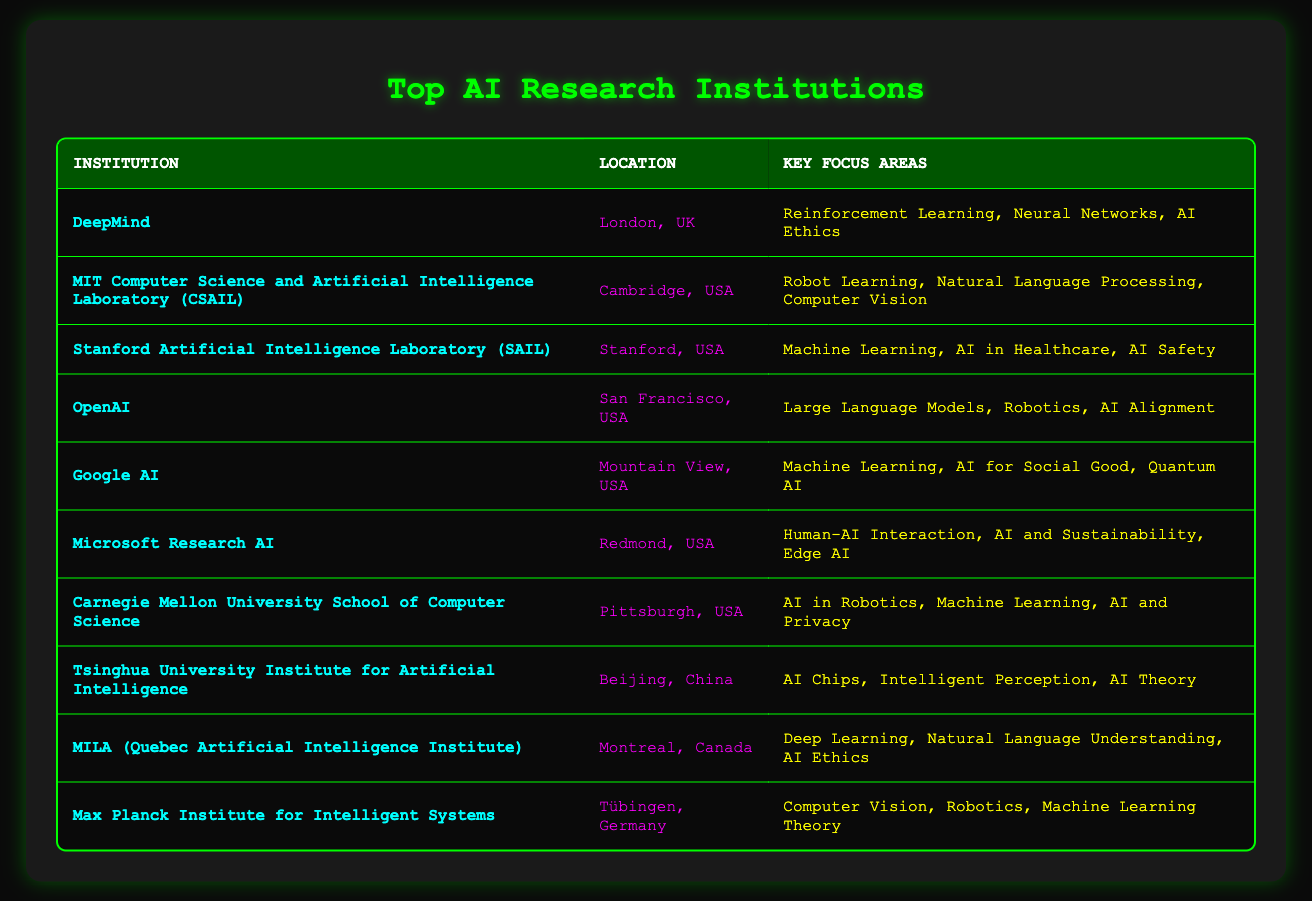What is the key focus area of DeepMind? The table shows that DeepMind's key focus areas are Reinforcement Learning, Neural Networks, and AI Ethics, which can be directly found in the row for DeepMind.
Answer: Reinforcement Learning, Neural Networks, AI Ethics Which institution is located in Cambridge, USA? By checking the 'Location' column in the table, MIT Computer Science and Artificial Intelligence Laboratory (CSAIL) is listed as located in Cambridge, USA.
Answer: MIT Computer Science and Artificial Intelligence Laboratory (CSAIL) Is Tsinghua University Institute for Artificial Intelligence focused on AI Ethics? The 'Key Focus Areas' for Tsinghua University are AI Chips, Intelligent Perception, and AI Theory. Since AI Ethics is not listed, the answer is no.
Answer: No Which two institutions focus on AI Ethics? The focus area column indicates that both DeepMind and MILA have AI Ethics listed among their key focus areas. Thus, they are the two institutions that focus on AI Ethics.
Answer: DeepMind, MILA How many institutions focus on Machine Learning? The focus areas indicate that DeepMind, Stanford SAIL, Google AI, Microsoft Research AI, Carnegie Mellon, and Max Planck Institute for Intelligent Systems all mention Machine Learning as a key focus area. This gives a total of 6 institutions.
Answer: 6 Does the OpenAI focus on Robotics? The OpenAI key focus area includes Robotics, which can be confirmed by looking at the respective row. Therefore, the answer is yes.
Answer: Yes Which institution has a focus area of AI for Social Good? According to the table, Google AI is the institution that lists AI for Social Good as one of its key focus areas.
Answer: Google AI What is the key focus area that all institutions have in common? Upon reviewing the table, there is no single key focus area that is mentioned by all institutions. However, 'Machine Learning' is mentioned by multiple institutions.
Answer: None (no common focus area) Which institution has its location in Tübingen, Germany? The table clearly states that the Max Planck Institute for Intelligent Systems is located in Tübingen, Germany.
Answer: Max Planck Institute for Intelligent Systems 